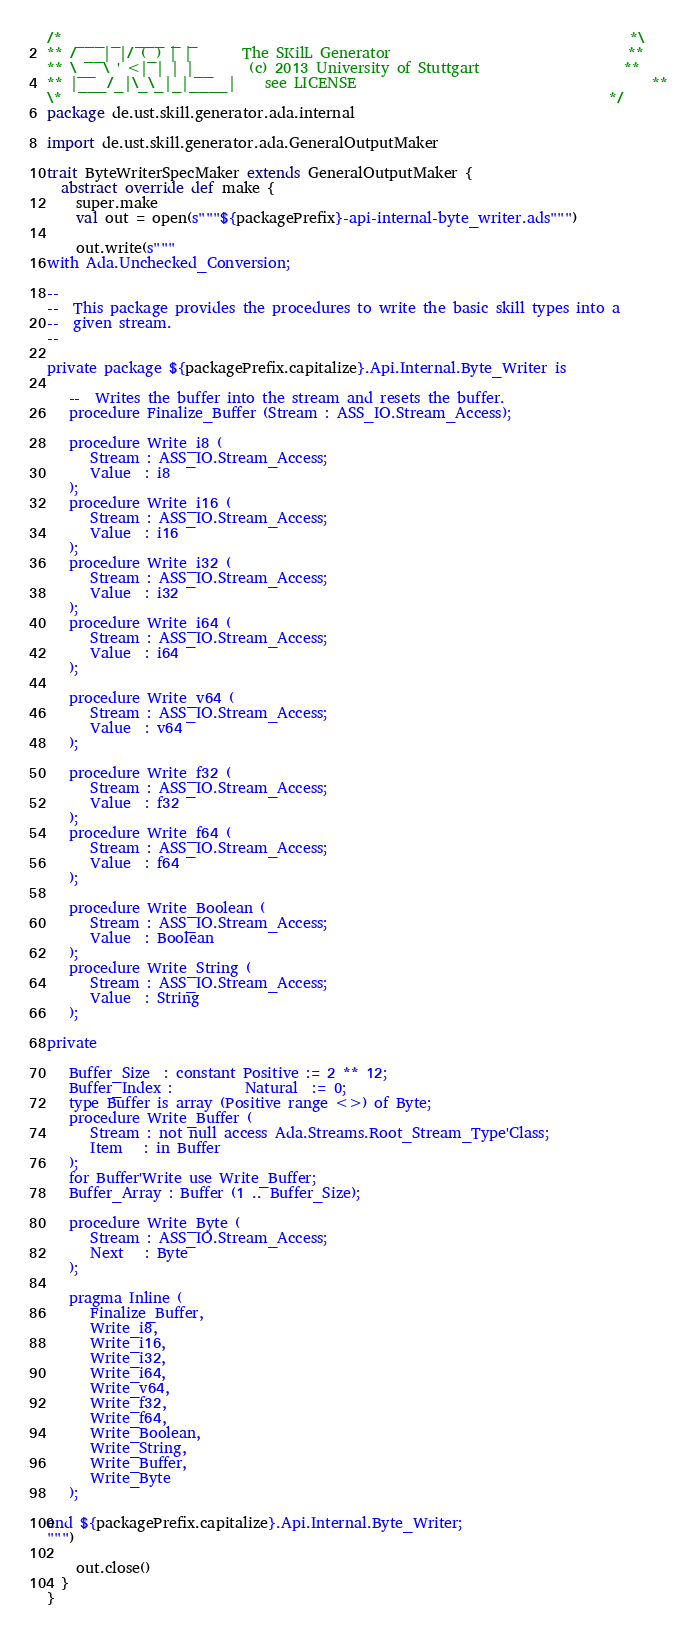<code> <loc_0><loc_0><loc_500><loc_500><_Scala_>/*  ___ _  ___ _ _                                                            *\
** / __| |/ (_) | |       The SKilL Generator                                 **
** \__ \ ' <| | | |__     (c) 2013 University of Stuttgart                    **
** |___/_|\_\_|_|____|    see LICENSE                                         **
\*                                                                            */
package de.ust.skill.generator.ada.internal

import de.ust.skill.generator.ada.GeneralOutputMaker

trait ByteWriterSpecMaker extends GeneralOutputMaker {
  abstract override def make {
    super.make
    val out = open(s"""${packagePrefix}-api-internal-byte_writer.ads""")

    out.write(s"""
with Ada.Unchecked_Conversion;

--
--  This package provides the procedures to write the basic skill types into a
--  given stream.
--

private package ${packagePrefix.capitalize}.Api.Internal.Byte_Writer is

   --  Writes the buffer into the stream and resets the buffer.
   procedure Finalize_Buffer (Stream : ASS_IO.Stream_Access);

   procedure Write_i8 (
      Stream : ASS_IO.Stream_Access;
      Value  : i8
   );
   procedure Write_i16 (
      Stream : ASS_IO.Stream_Access;
      Value  : i16
   );
   procedure Write_i32 (
      Stream : ASS_IO.Stream_Access;
      Value  : i32
   );
   procedure Write_i64 (
      Stream : ASS_IO.Stream_Access;
      Value  : i64
   );

   procedure Write_v64 (
      Stream : ASS_IO.Stream_Access;
      Value  : v64
   );

   procedure Write_f32 (
      Stream : ASS_IO.Stream_Access;
      Value  : f32
   );
   procedure Write_f64 (
      Stream : ASS_IO.Stream_Access;
      Value  : f64
   );

   procedure Write_Boolean (
      Stream : ASS_IO.Stream_Access;
      Value  : Boolean
   );
   procedure Write_String (
      Stream : ASS_IO.Stream_Access;
      Value  : String
   );

private

   Buffer_Size  : constant Positive := 2 ** 12;
   Buffer_Index :          Natural  := 0;
   type Buffer is array (Positive range <>) of Byte;
   procedure Write_Buffer (
      Stream : not null access Ada.Streams.Root_Stream_Type'Class;
      Item   : in Buffer
   );
   for Buffer'Write use Write_Buffer;
   Buffer_Array : Buffer (1 .. Buffer_Size);

   procedure Write_Byte (
      Stream : ASS_IO.Stream_Access;
      Next   : Byte
   );

   pragma Inline (
      Finalize_Buffer,
      Write_i8,
      Write_i16,
      Write_i32,
      Write_i64,
      Write_v64,
      Write_f32,
      Write_f64,
      Write_Boolean,
      Write_String,
      Write_Buffer,
      Write_Byte
   );

end ${packagePrefix.capitalize}.Api.Internal.Byte_Writer;
""")

    out.close()
  }
}
</code> 